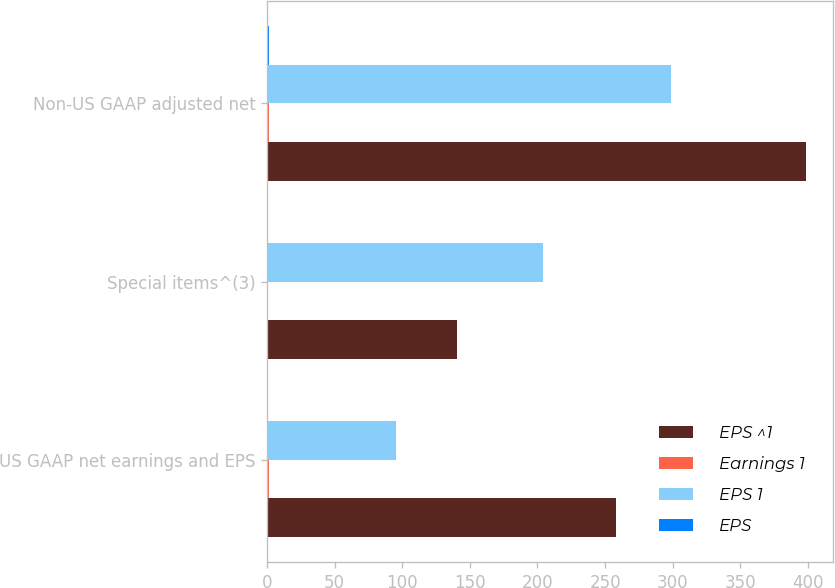Convert chart. <chart><loc_0><loc_0><loc_500><loc_500><stacked_bar_chart><ecel><fcel>US GAAP net earnings and EPS<fcel>Special items^(3)<fcel>Non-US GAAP adjusted net<nl><fcel>EPS ^1<fcel>258.1<fcel>140.8<fcel>398.9<nl><fcel>Earnings 1<fcel>1.2<fcel>0.66<fcel>1.86<nl><fcel>EPS 1<fcel>95.3<fcel>203.8<fcel>299.1<nl><fcel>EPS<fcel>0.44<fcel>0.95<fcel>1.39<nl></chart> 